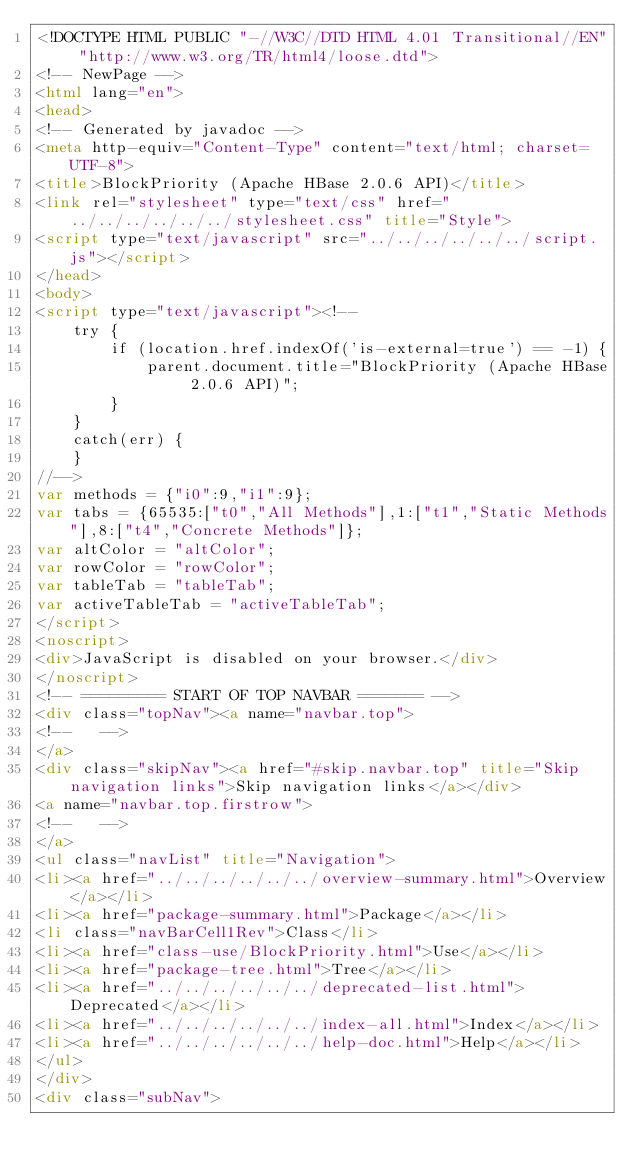<code> <loc_0><loc_0><loc_500><loc_500><_HTML_><!DOCTYPE HTML PUBLIC "-//W3C//DTD HTML 4.01 Transitional//EN" "http://www.w3.org/TR/html4/loose.dtd">
<!-- NewPage -->
<html lang="en">
<head>
<!-- Generated by javadoc -->
<meta http-equiv="Content-Type" content="text/html; charset=UTF-8">
<title>BlockPriority (Apache HBase 2.0.6 API)</title>
<link rel="stylesheet" type="text/css" href="../../../../../../stylesheet.css" title="Style">
<script type="text/javascript" src="../../../../../../script.js"></script>
</head>
<body>
<script type="text/javascript"><!--
    try {
        if (location.href.indexOf('is-external=true') == -1) {
            parent.document.title="BlockPriority (Apache HBase 2.0.6 API)";
        }
    }
    catch(err) {
    }
//-->
var methods = {"i0":9,"i1":9};
var tabs = {65535:["t0","All Methods"],1:["t1","Static Methods"],8:["t4","Concrete Methods"]};
var altColor = "altColor";
var rowColor = "rowColor";
var tableTab = "tableTab";
var activeTableTab = "activeTableTab";
</script>
<noscript>
<div>JavaScript is disabled on your browser.</div>
</noscript>
<!-- ========= START OF TOP NAVBAR ======= -->
<div class="topNav"><a name="navbar.top">
<!--   -->
</a>
<div class="skipNav"><a href="#skip.navbar.top" title="Skip navigation links">Skip navigation links</a></div>
<a name="navbar.top.firstrow">
<!--   -->
</a>
<ul class="navList" title="Navigation">
<li><a href="../../../../../../overview-summary.html">Overview</a></li>
<li><a href="package-summary.html">Package</a></li>
<li class="navBarCell1Rev">Class</li>
<li><a href="class-use/BlockPriority.html">Use</a></li>
<li><a href="package-tree.html">Tree</a></li>
<li><a href="../../../../../../deprecated-list.html">Deprecated</a></li>
<li><a href="../../../../../../index-all.html">Index</a></li>
<li><a href="../../../../../../help-doc.html">Help</a></li>
</ul>
</div>
<div class="subNav"></code> 